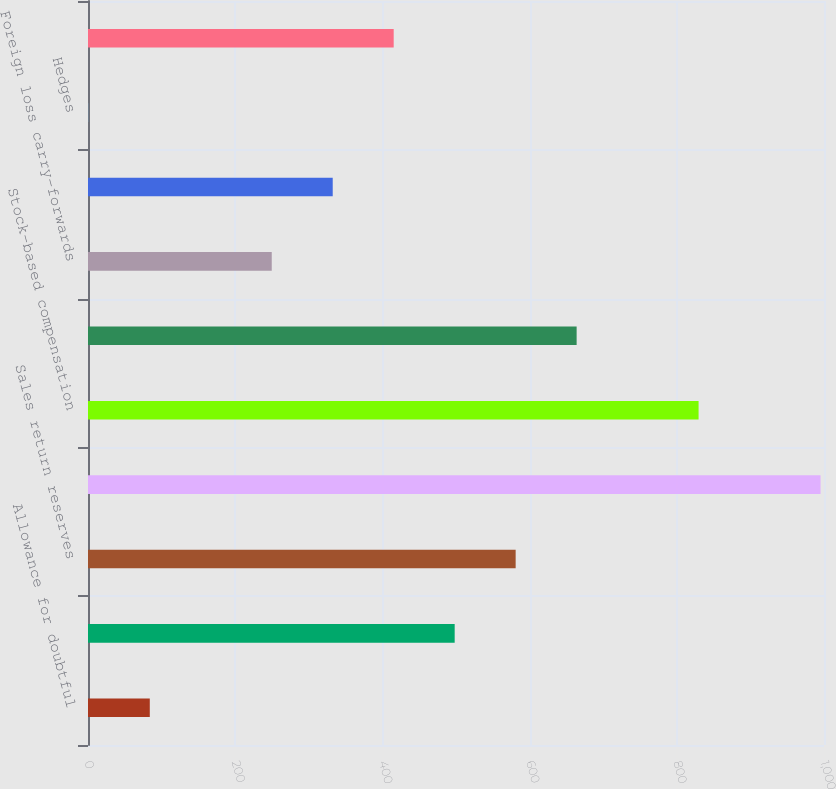<chart> <loc_0><loc_0><loc_500><loc_500><bar_chart><fcel>Allowance for doubtful<fcel>Inventories<fcel>Sales return reserves<fcel>Deferred compensation<fcel>Stock-based compensation<fcel>Reserves and accrued<fcel>Foreign loss carry-forwards<fcel>Foreign tax credit<fcel>Hedges<fcel>Other<nl><fcel>83.95<fcel>498.2<fcel>581.05<fcel>995.3<fcel>829.6<fcel>663.9<fcel>249.65<fcel>332.5<fcel>1.1<fcel>415.35<nl></chart> 